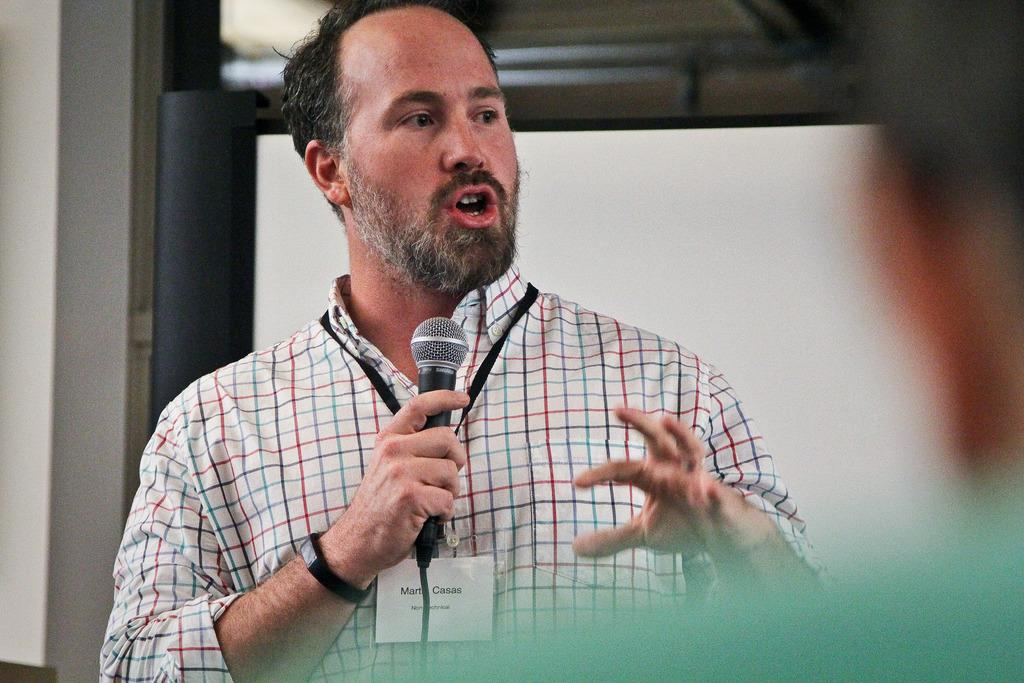Who is the main subject in the image? There is a man in the image. What is the man holding in the image? The man is holding a microphone. Can you describe any additional accessories the man is wearing? The man is wearing an ID card. What type of comfort can be seen in the image? There is no specific comfort depicted in the image; it features a man holding a microphone and wearing an ID card. What cause is the man advocating for in the image? There is no indication of a cause or advocacy in the image; it simply shows a man holding a microphone and wearing an ID card. 